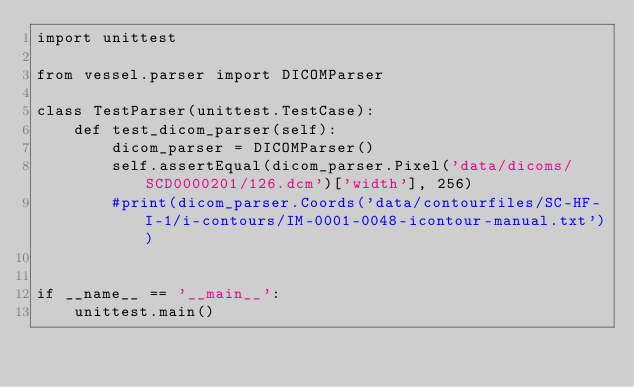Convert code to text. <code><loc_0><loc_0><loc_500><loc_500><_Python_>import unittest

from vessel.parser import DICOMParser

class TestParser(unittest.TestCase):  
    def test_dicom_parser(self):
        dicom_parser = DICOMParser()
        self.assertEqual(dicom_parser.Pixel('data/dicoms/SCD0000201/126.dcm')['width'], 256)
        #print(dicom_parser.Coords('data/contourfiles/SC-HF-I-1/i-contours/IM-0001-0048-icontour-manual.txt'))


if __name__ == '__main__':
    unittest.main()
</code> 